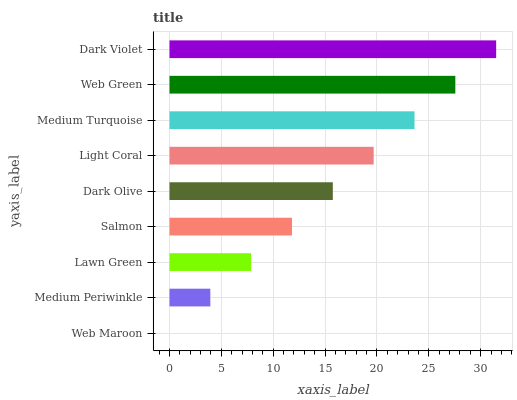Is Web Maroon the minimum?
Answer yes or no. Yes. Is Dark Violet the maximum?
Answer yes or no. Yes. Is Medium Periwinkle the minimum?
Answer yes or no. No. Is Medium Periwinkle the maximum?
Answer yes or no. No. Is Medium Periwinkle greater than Web Maroon?
Answer yes or no. Yes. Is Web Maroon less than Medium Periwinkle?
Answer yes or no. Yes. Is Web Maroon greater than Medium Periwinkle?
Answer yes or no. No. Is Medium Periwinkle less than Web Maroon?
Answer yes or no. No. Is Dark Olive the high median?
Answer yes or no. Yes. Is Dark Olive the low median?
Answer yes or no. Yes. Is Medium Turquoise the high median?
Answer yes or no. No. Is Web Green the low median?
Answer yes or no. No. 